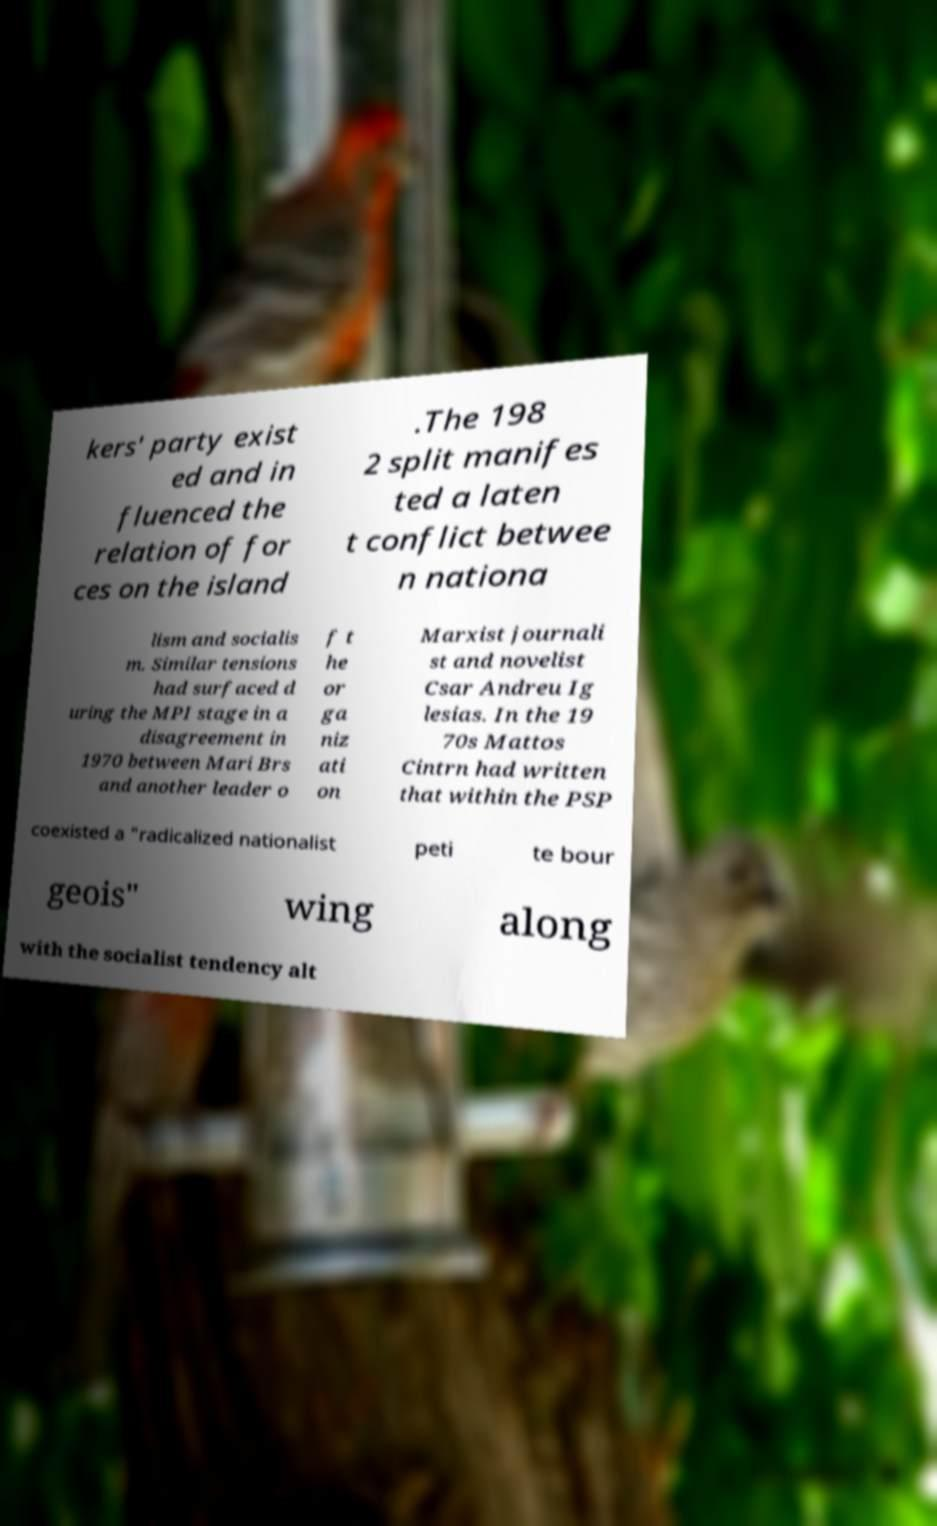Please identify and transcribe the text found in this image. kers' party exist ed and in fluenced the relation of for ces on the island .The 198 2 split manifes ted a laten t conflict betwee n nationa lism and socialis m. Similar tensions had surfaced d uring the MPI stage in a disagreement in 1970 between Mari Brs and another leader o f t he or ga niz ati on Marxist journali st and novelist Csar Andreu Ig lesias. In the 19 70s Mattos Cintrn had written that within the PSP coexisted a "radicalized nationalist peti te bour geois" wing along with the socialist tendency alt 